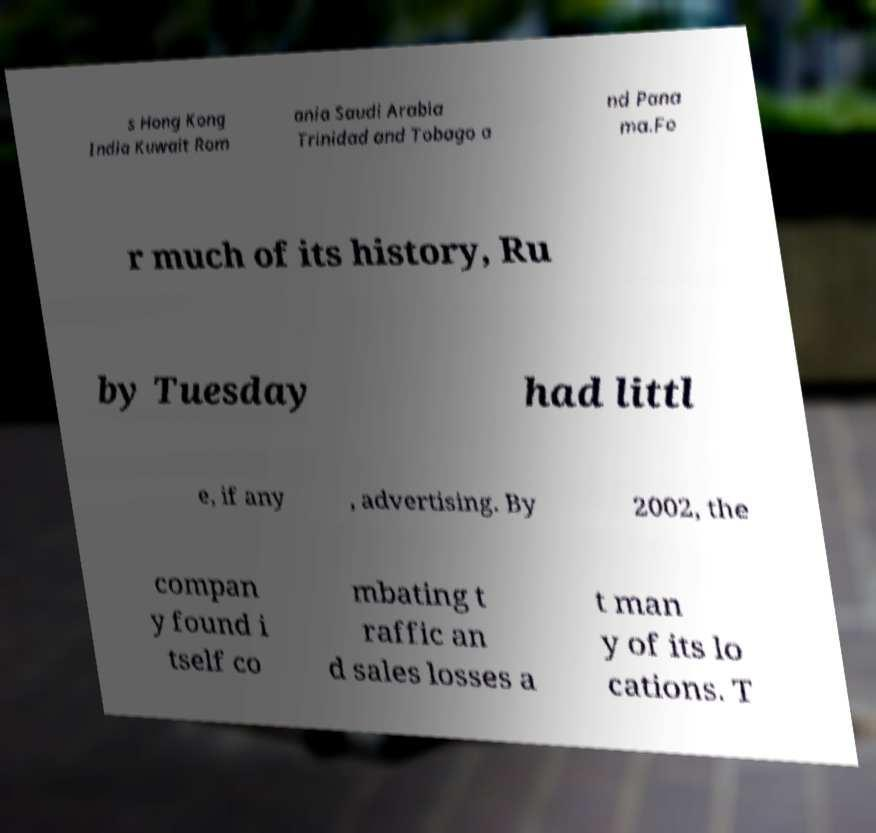There's text embedded in this image that I need extracted. Can you transcribe it verbatim? s Hong Kong India Kuwait Rom ania Saudi Arabia Trinidad and Tobago a nd Pana ma.Fo r much of its history, Ru by Tuesday had littl e, if any , advertising. By 2002, the compan y found i tself co mbating t raffic an d sales losses a t man y of its lo cations. T 